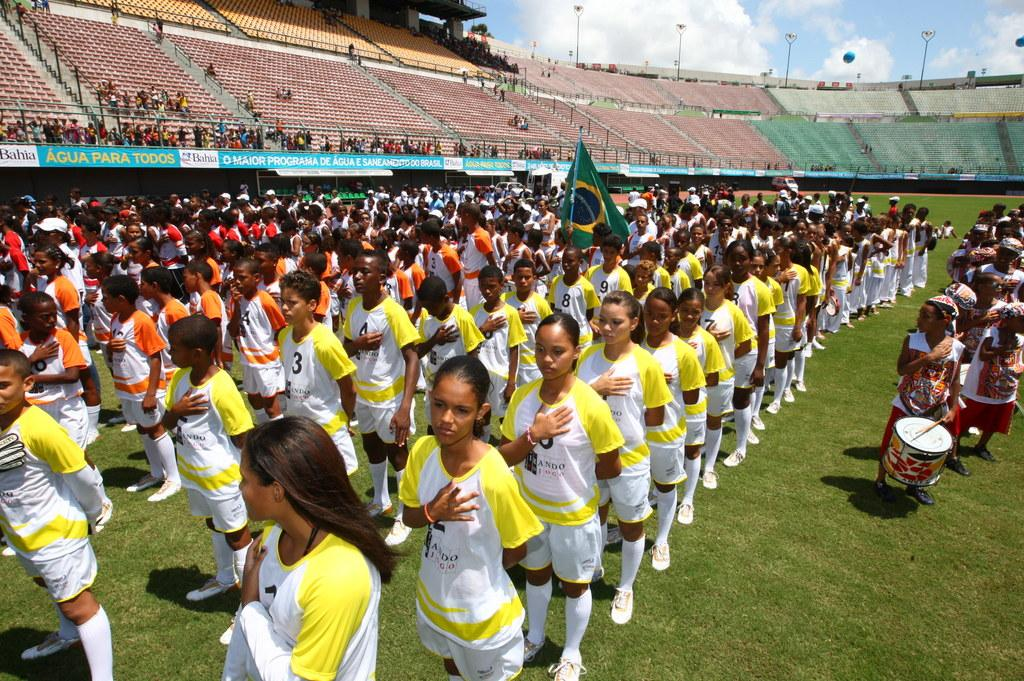What is the setting of the image? The image is set in a stadium. Who is present in the image? There is a group of girls and boys in the image. What can be seen in the background of the image? There are stadium seats for the audience in the background. What is visible in the sky in the image? The sky is visible in the image, and clouds are present. What type of event is the grandmother attending in the image? There is no grandmother present in the image, and no event is mentioned or depicted. 